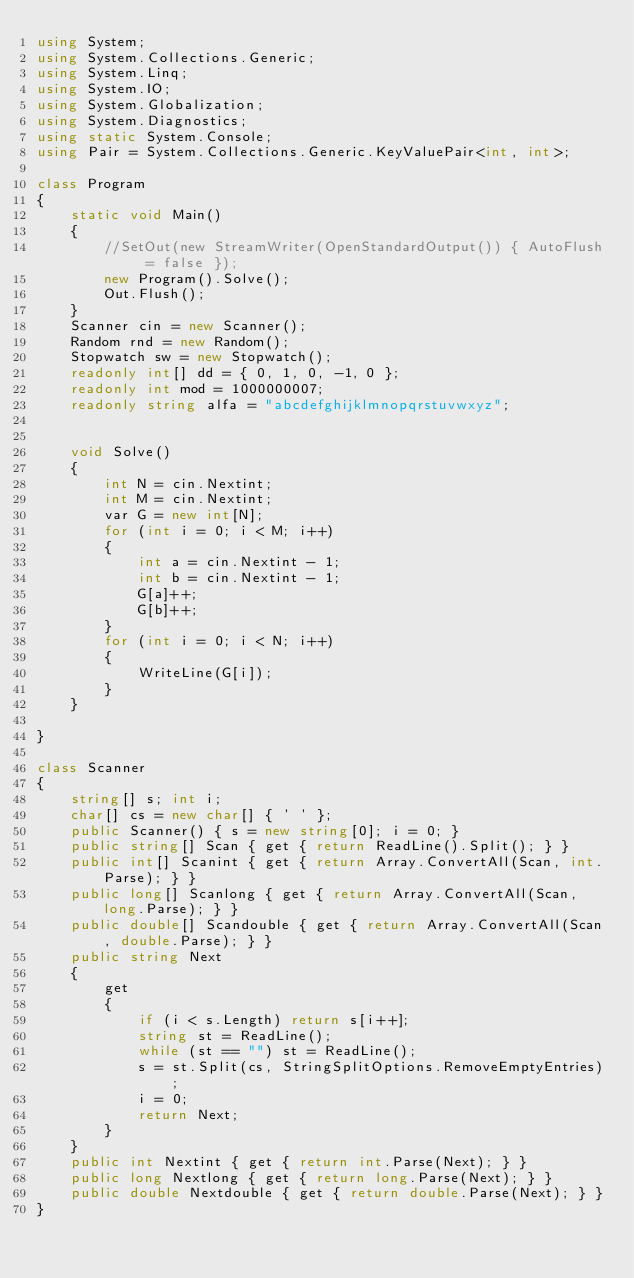Convert code to text. <code><loc_0><loc_0><loc_500><loc_500><_C#_>using System;
using System.Collections.Generic;
using System.Linq;
using System.IO;
using System.Globalization;
using System.Diagnostics;
using static System.Console;
using Pair = System.Collections.Generic.KeyValuePair<int, int>;

class Program
{
    static void Main()
    {
        //SetOut(new StreamWriter(OpenStandardOutput()) { AutoFlush = false });
        new Program().Solve();
        Out.Flush();
    }
    Scanner cin = new Scanner();
    Random rnd = new Random();
    Stopwatch sw = new Stopwatch();
    readonly int[] dd = { 0, 1, 0, -1, 0 };
    readonly int mod = 1000000007;
    readonly string alfa = "abcdefghijklmnopqrstuvwxyz";


    void Solve()
    {
        int N = cin.Nextint;
        int M = cin.Nextint;
        var G = new int[N];
        for (int i = 0; i < M; i++)
        {
            int a = cin.Nextint - 1;
            int b = cin.Nextint - 1;
            G[a]++;
            G[b]++;
        }
        for (int i = 0; i < N; i++)
        {
            WriteLine(G[i]);
        }
    }

}

class Scanner
{
    string[] s; int i;
    char[] cs = new char[] { ' ' };
    public Scanner() { s = new string[0]; i = 0; }
    public string[] Scan { get { return ReadLine().Split(); } }
    public int[] Scanint { get { return Array.ConvertAll(Scan, int.Parse); } }
    public long[] Scanlong { get { return Array.ConvertAll(Scan, long.Parse); } }
    public double[] Scandouble { get { return Array.ConvertAll(Scan, double.Parse); } }
    public string Next
    {
        get
        {
            if (i < s.Length) return s[i++];
            string st = ReadLine();
            while (st == "") st = ReadLine();
            s = st.Split(cs, StringSplitOptions.RemoveEmptyEntries);
            i = 0;
            return Next;
        }
    }
    public int Nextint { get { return int.Parse(Next); } }
    public long Nextlong { get { return long.Parse(Next); } }
    public double Nextdouble { get { return double.Parse(Next); } }
}</code> 